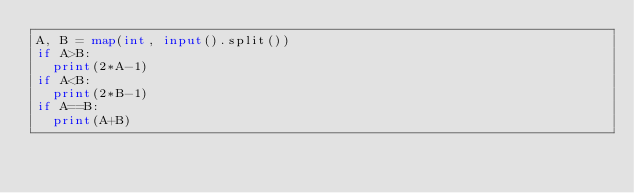Convert code to text. <code><loc_0><loc_0><loc_500><loc_500><_Python_>A, B = map(int, input().split())
if A>B:
  print(2*A-1)
if A<B:
  print(2*B-1)
if A==B:
  print(A+B)</code> 